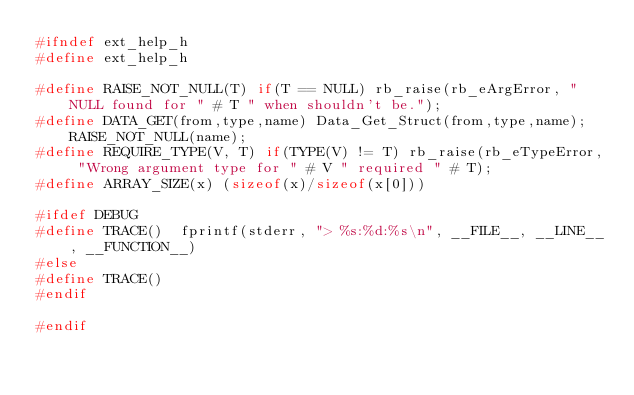Convert code to text. <code><loc_0><loc_0><loc_500><loc_500><_C_>#ifndef ext_help_h
#define ext_help_h

#define RAISE_NOT_NULL(T) if(T == NULL) rb_raise(rb_eArgError, "NULL found for " # T " when shouldn't be.");
#define DATA_GET(from,type,name) Data_Get_Struct(from,type,name); RAISE_NOT_NULL(name);
#define REQUIRE_TYPE(V, T) if(TYPE(V) != T) rb_raise(rb_eTypeError, "Wrong argument type for " # V " required " # T);
#define ARRAY_SIZE(x) (sizeof(x)/sizeof(x[0]))

#ifdef DEBUG
#define TRACE()  fprintf(stderr, "> %s:%d:%s\n", __FILE__, __LINE__, __FUNCTION__)
#else
#define TRACE() 
#endif

#endif
</code> 